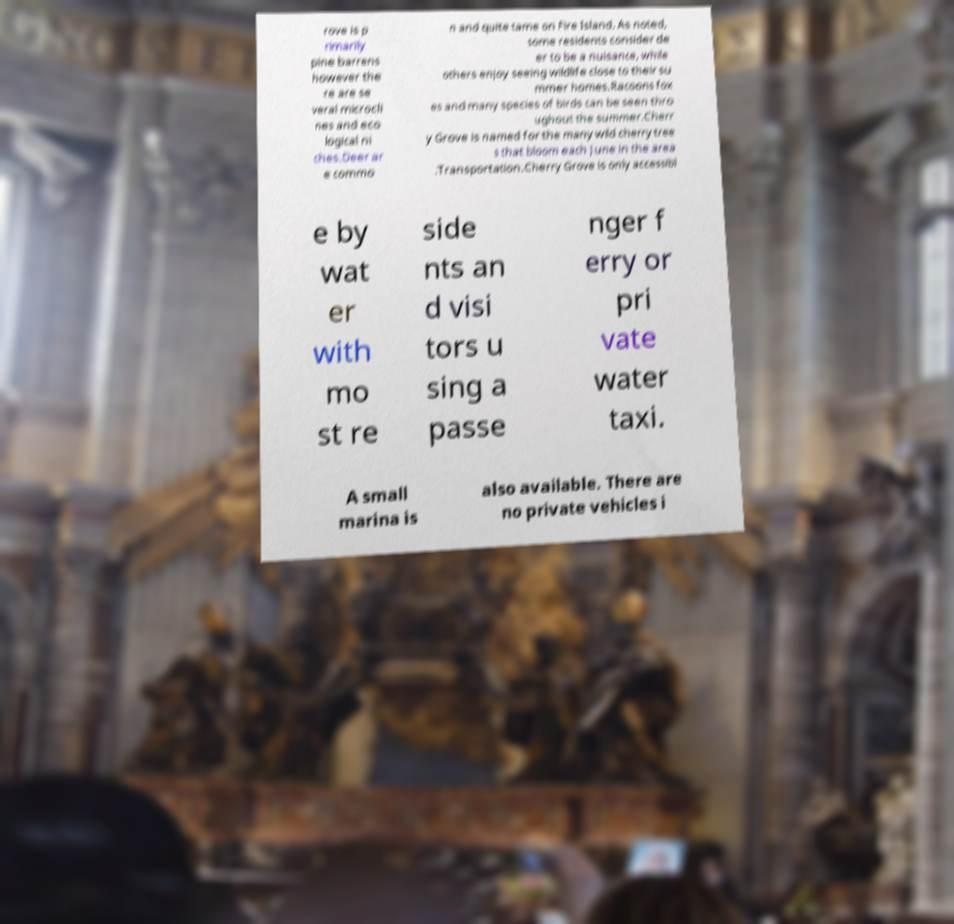For documentation purposes, I need the text within this image transcribed. Could you provide that? rove is p rimarily pine barrens however the re are se veral microcli nes and eco logical ni ches.Deer ar e commo n and quite tame on Fire Island. As noted, some residents consider de er to be a nuisance, while others enjoy seeing wildlife close to their su mmer homes.Racoons fox es and many species of birds can be seen thro ughout the summer.Cherr y Grove is named for the many wild cherry tree s that bloom each June in the area .Transportation.Cherry Grove is only accessibl e by wat er with mo st re side nts an d visi tors u sing a passe nger f erry or pri vate water taxi. A small marina is also available. There are no private vehicles i 